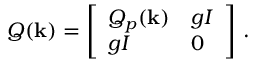Convert formula to latex. <formula><loc_0><loc_0><loc_500><loc_500>Q ( \mathbf k ) = \left [ \begin{array} { l l } { Q _ { p } ( \mathbf k ) } & { g I } \\ { g I } & { 0 } \end{array} \right ] \, .</formula> 